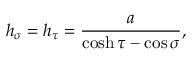<formula> <loc_0><loc_0><loc_500><loc_500>h _ { \sigma } = h _ { \tau } = \frac { a } { \cosh \tau - \cos \sigma } ,</formula> 